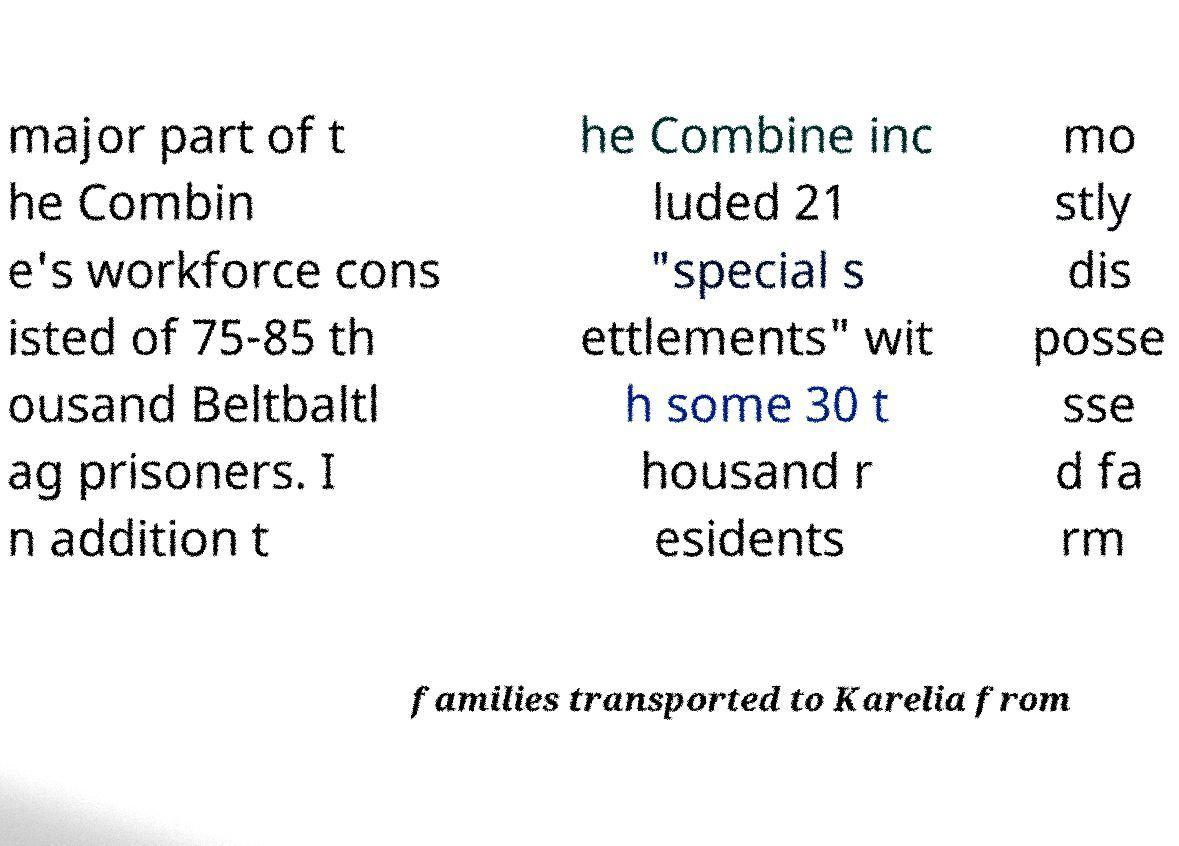Can you read and provide the text displayed in the image?This photo seems to have some interesting text. Can you extract and type it out for me? major part of t he Combin e's workforce cons isted of 75-85 th ousand Beltbaltl ag prisoners. I n addition t he Combine inc luded 21 "special s ettlements" wit h some 30 t housand r esidents mo stly dis posse sse d fa rm families transported to Karelia from 